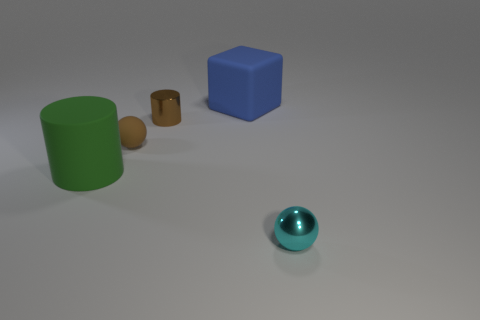Do the rubber cube and the thing in front of the green object have the same size?
Ensure brevity in your answer.  No. Are there fewer small rubber balls that are behind the small brown matte thing than tiny cyan shiny balls that are right of the small cyan thing?
Give a very brief answer. No. There is a rubber thing left of the brown sphere; what is its size?
Keep it short and to the point. Large. Is the size of the blue matte block the same as the cyan object?
Offer a very short reply. No. What number of spheres are in front of the big green cylinder and left of the tiny metal sphere?
Your answer should be very brief. 0. How many yellow things are either metal things or tiny shiny balls?
Provide a short and direct response. 0. What number of shiny things are small brown balls or large green blocks?
Ensure brevity in your answer.  0. Are there any green matte objects?
Keep it short and to the point. Yes. Is the large blue matte thing the same shape as the brown matte object?
Offer a terse response. No. There is a rubber object right of the ball that is on the left side of the large block; what number of balls are to the left of it?
Your response must be concise. 1. 